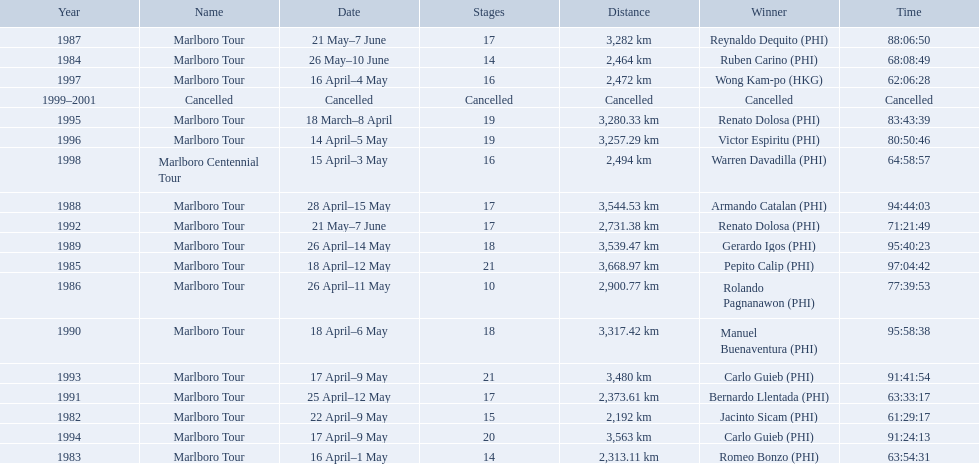Who were all of the winners? Jacinto Sicam (PHI), Romeo Bonzo (PHI), Ruben Carino (PHI), Pepito Calip (PHI), Rolando Pagnanawon (PHI), Reynaldo Dequito (PHI), Armando Catalan (PHI), Gerardo Igos (PHI), Manuel Buenaventura (PHI), Bernardo Llentada (PHI), Renato Dolosa (PHI), Carlo Guieb (PHI), Carlo Guieb (PHI), Renato Dolosa (PHI), Victor Espiritu (PHI), Wong Kam-po (HKG), Warren Davadilla (PHI), Cancelled. When did they compete? 1982, 1983, 1984, 1985, 1986, 1987, 1988, 1989, 1990, 1991, 1992, 1993, 1994, 1995, 1996, 1997, 1998, 1999–2001. What were their finishing times? 61:29:17, 63:54:31, 68:08:49, 97:04:42, 77:39:53, 88:06:50, 94:44:03, 95:40:23, 95:58:38, 63:33:17, 71:21:49, 91:41:54, 91:24:13, 83:43:39, 80:50:46, 62:06:28, 64:58:57, Cancelled. And who won during 1998? Warren Davadilla (PHI). What was his time? 64:58:57. 